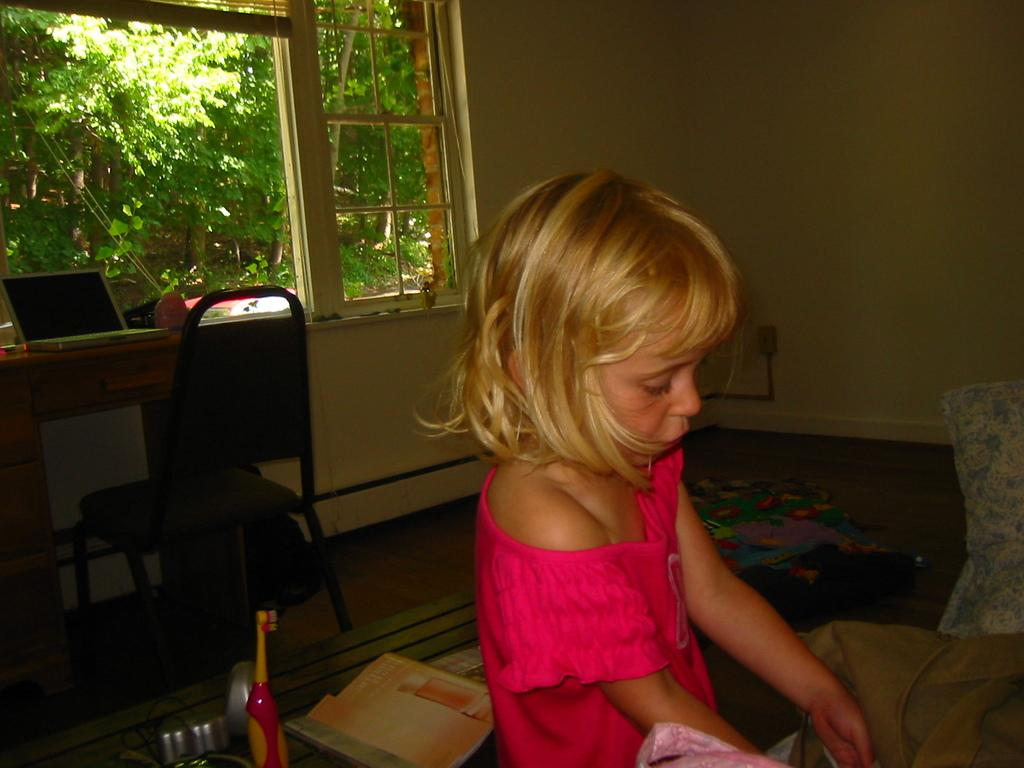Who is the main subject in the image? There is a girl in the image. What is the girl wearing? The girl is wearing a pink dress. What can be seen in the background of the image? There is a chair, a laptop, and trees in the background of the image. What type of cloth is the girl using to cover the laptop in the image? There is no cloth covering the laptop in the image; the laptop is visible in the background. 